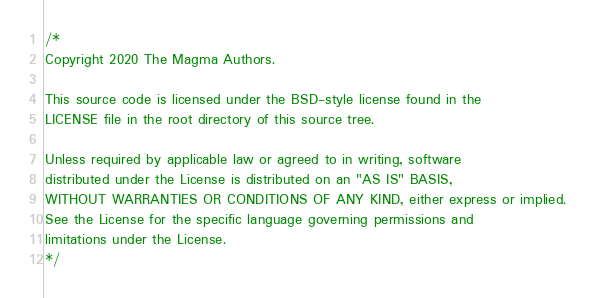<code> <loc_0><loc_0><loc_500><loc_500><_Go_>/*
Copyright 2020 The Magma Authors.

This source code is licensed under the BSD-style license found in the
LICENSE file in the root directory of this source tree.

Unless required by applicable law or agreed to in writing, software
distributed under the License is distributed on an "AS IS" BASIS,
WITHOUT WARRANTIES OR CONDITIONS OF ANY KIND, either express or implied.
See the License for the specific language governing permissions and
limitations under the License.
*/
</code> 